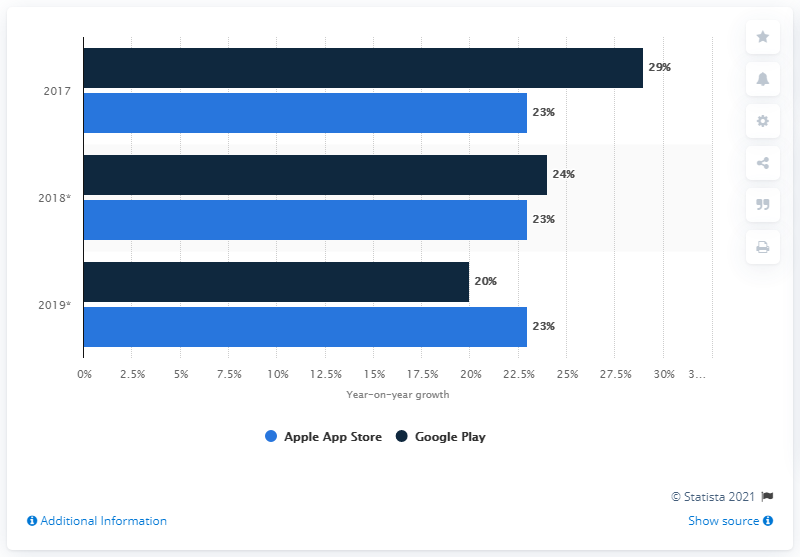Outline some significant characteristics in this image. In 2017, the year-on-year app revenue growth of the Apple App Store reached its highest level, with a significant increase of 23%. Google Play's highest year-on-year app revenue growth was from 2017 to 2019, with a growth rate of 29%. 